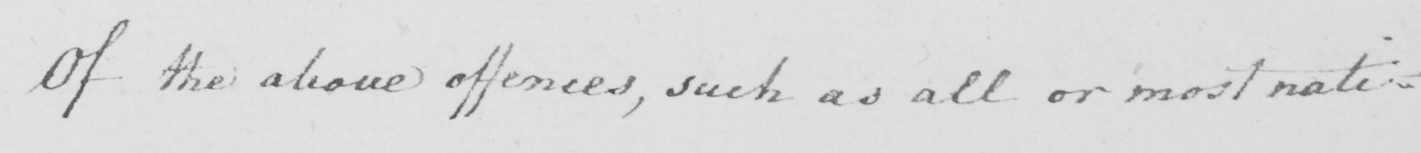Can you read and transcribe this handwriting? Of the above offences , such as all or most nati= 